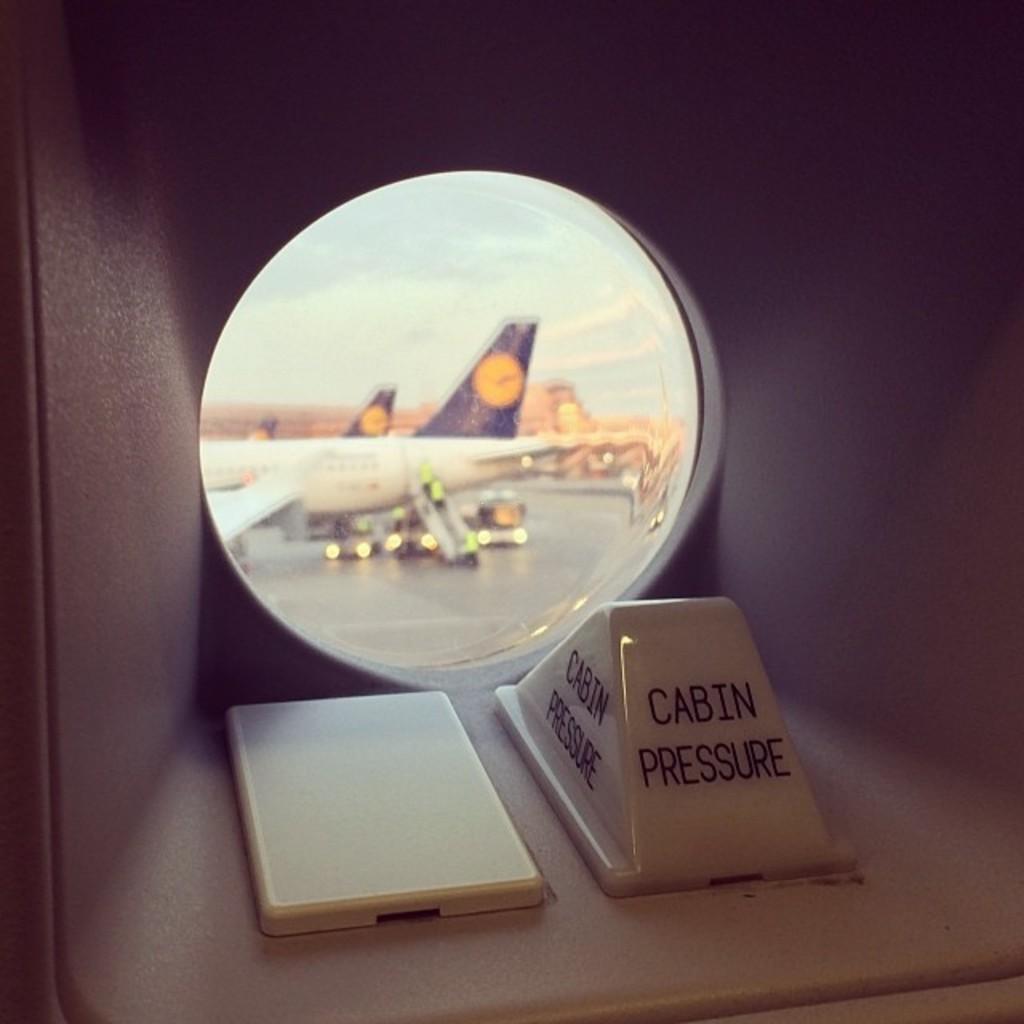In one or two sentences, can you explain what this image depicts? As we can see in the image there is a mirror. In mirror there is white color plane. 